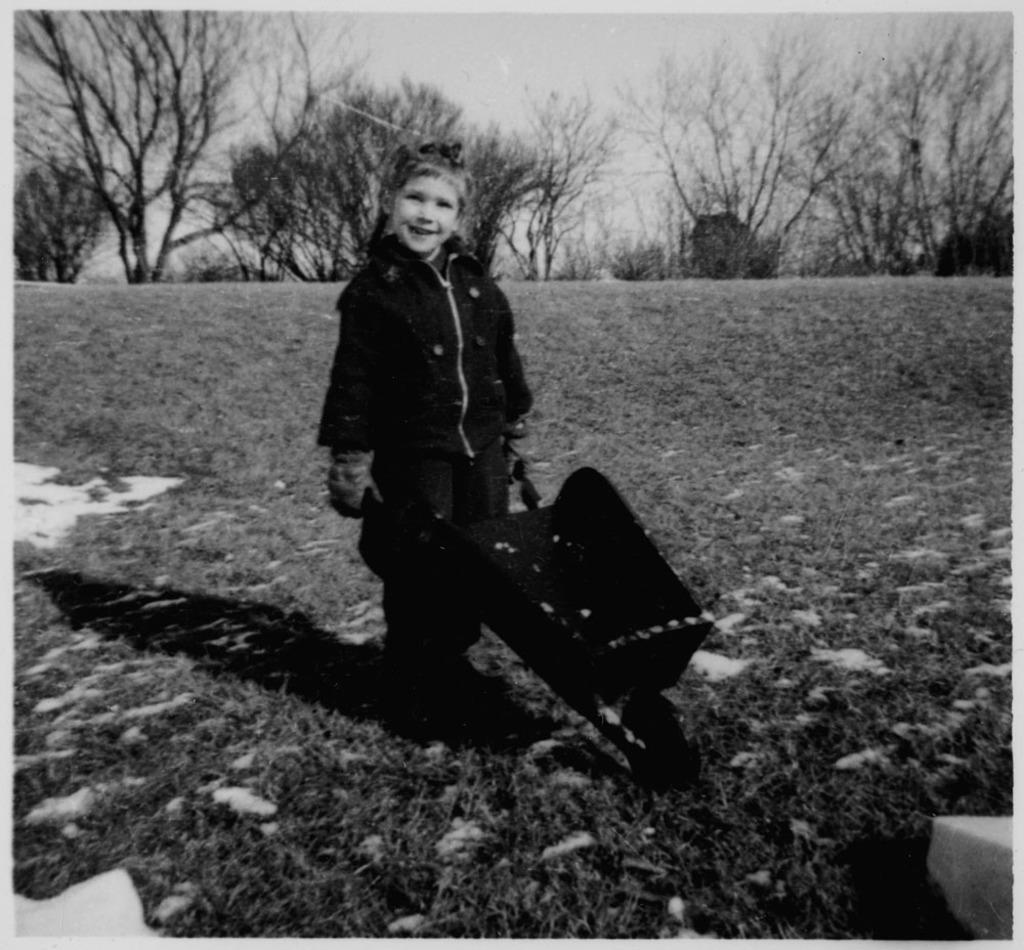Can you describe this image briefly? This is a black and white picture. In the background we can see trees. Here we can see a child standing and smiling. This is a black object on the ground. 